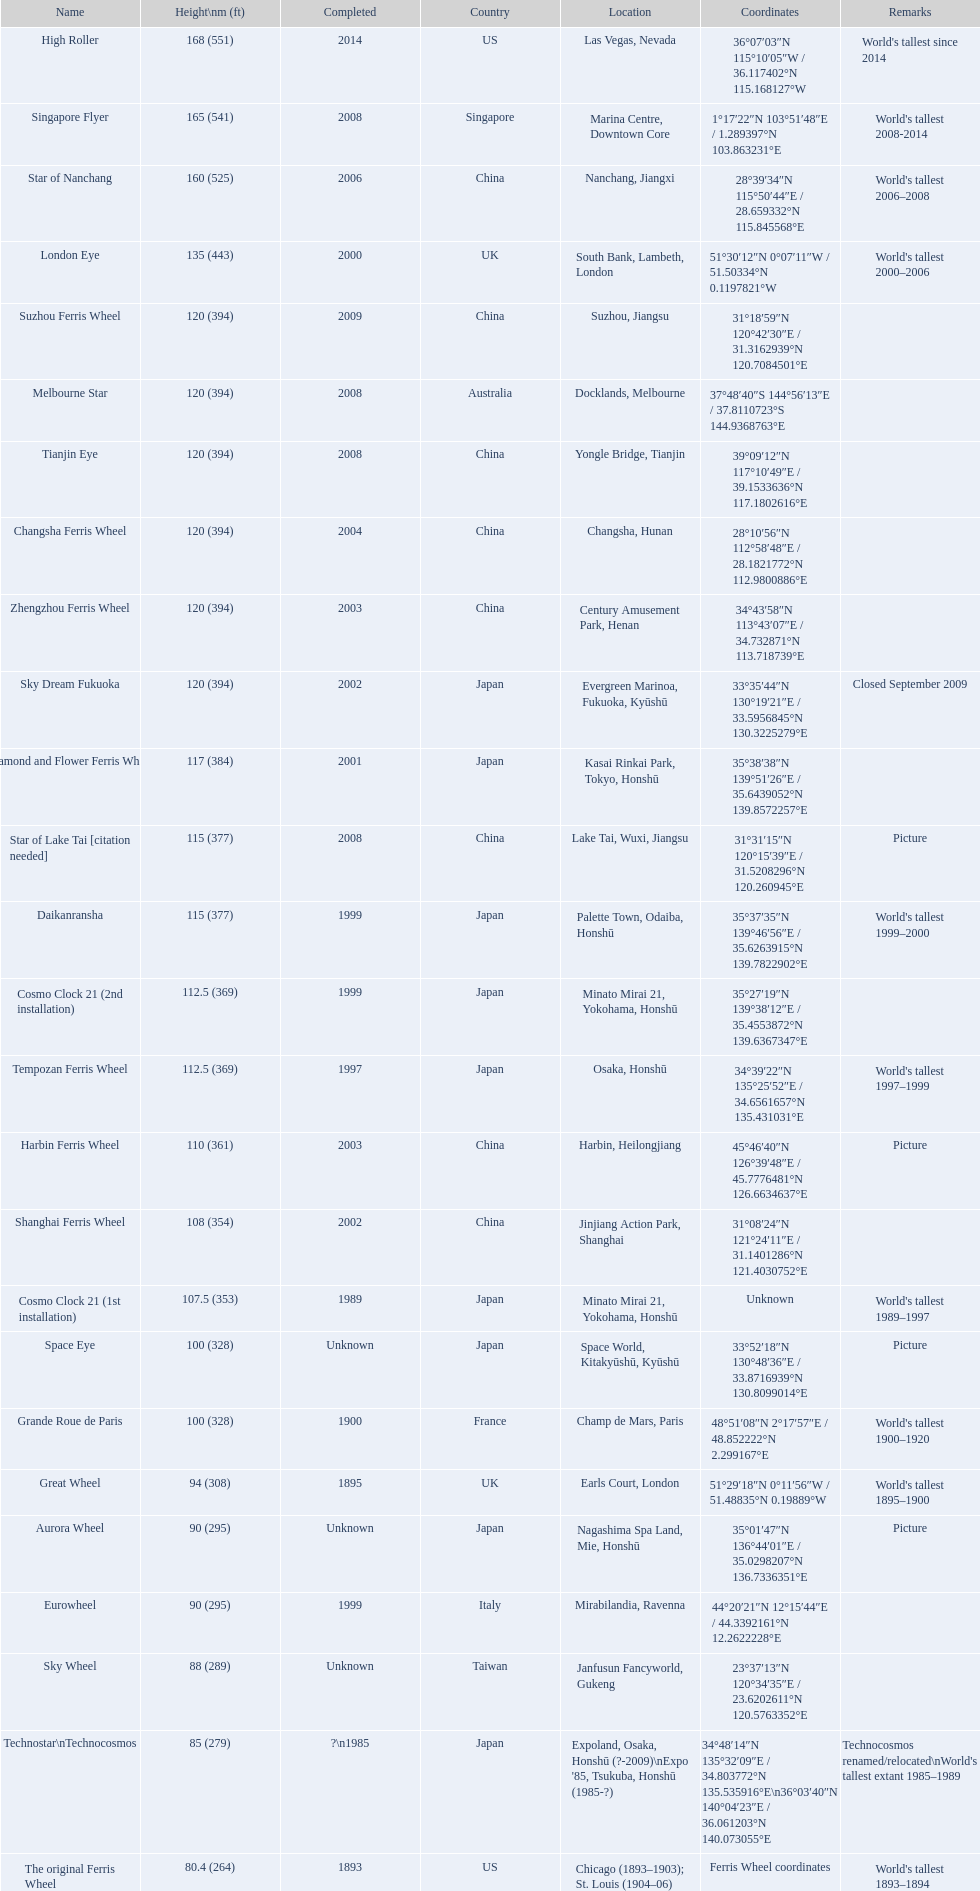When did the high roller ferris wheel reach completion? 2014. Which ferris wheel reached completion in 2006? Star of Nanchang. Which one achieved completion in 2008? Singapore Flyer. 